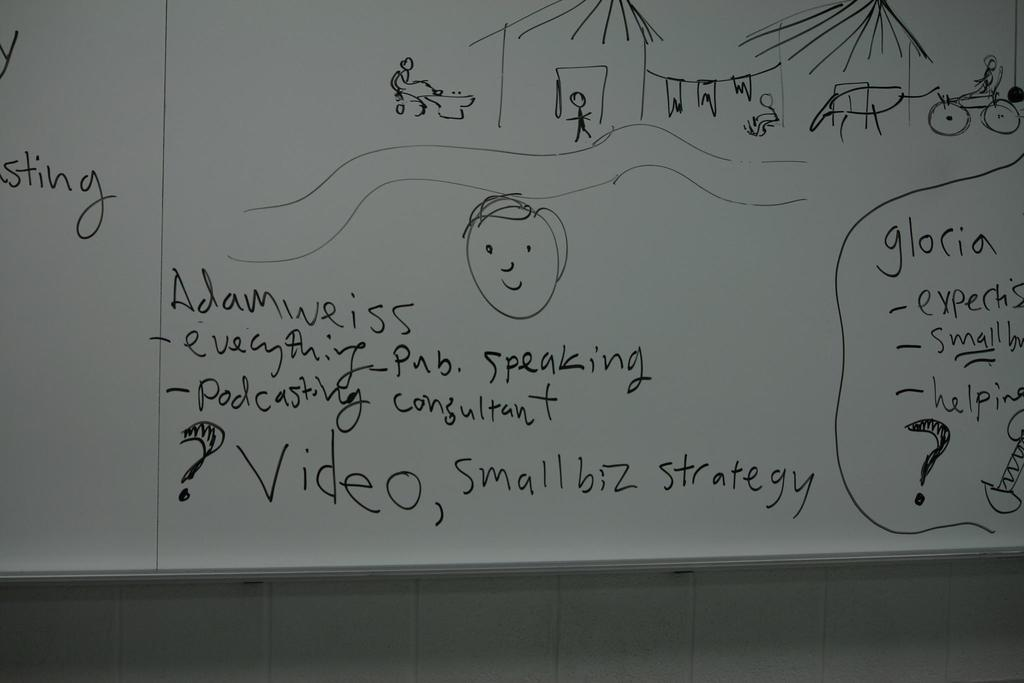What is the main object in the image? There is a whiteboard in the image. What is written or drawn on the whiteboard? The whiteboard has text on it and images attached to it. How is the whiteboard positioned in the image? The whiteboard is attached to the wall. Can you smell the air around the whiteboard in the image? The image does not provide any information about the smell or air around the whiteboard, so it cannot be determined from the image. 